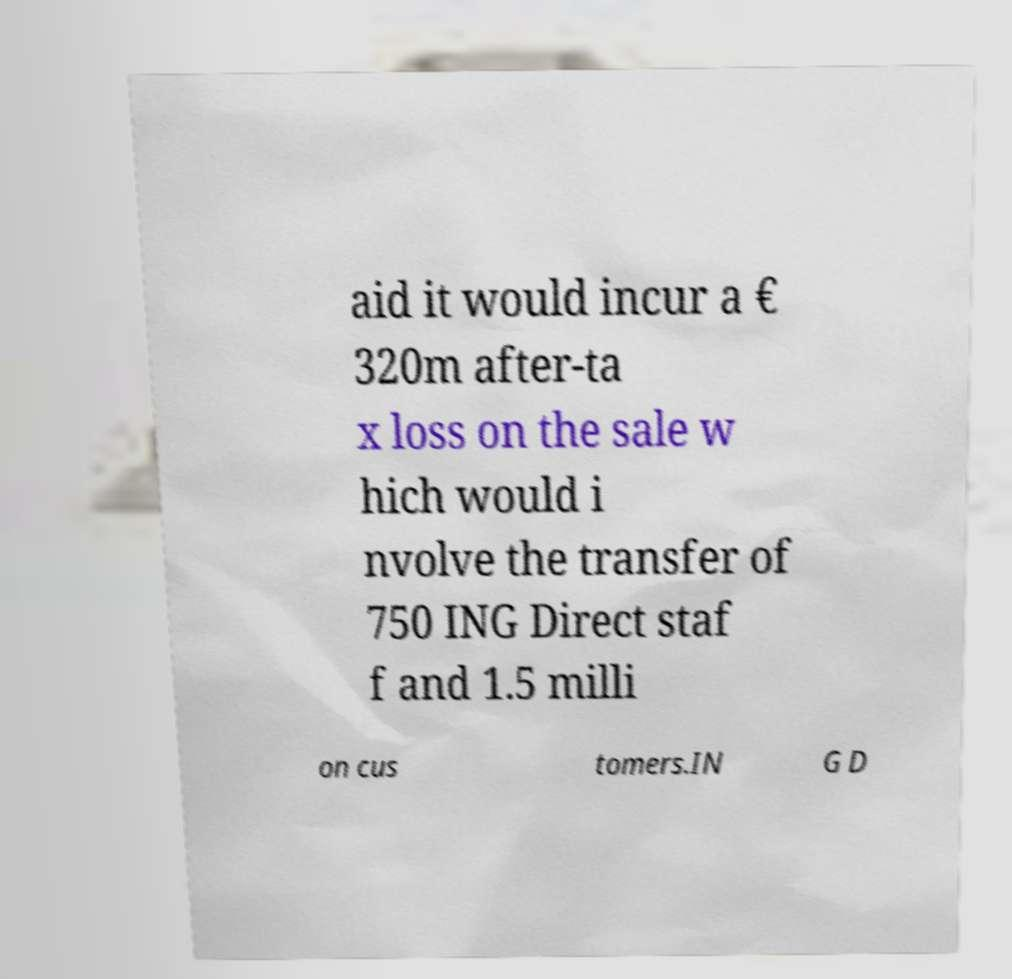Could you assist in decoding the text presented in this image and type it out clearly? aid it would incur a € 320m after-ta x loss on the sale w hich would i nvolve the transfer of 750 ING Direct staf f and 1.5 milli on cus tomers.IN G D 